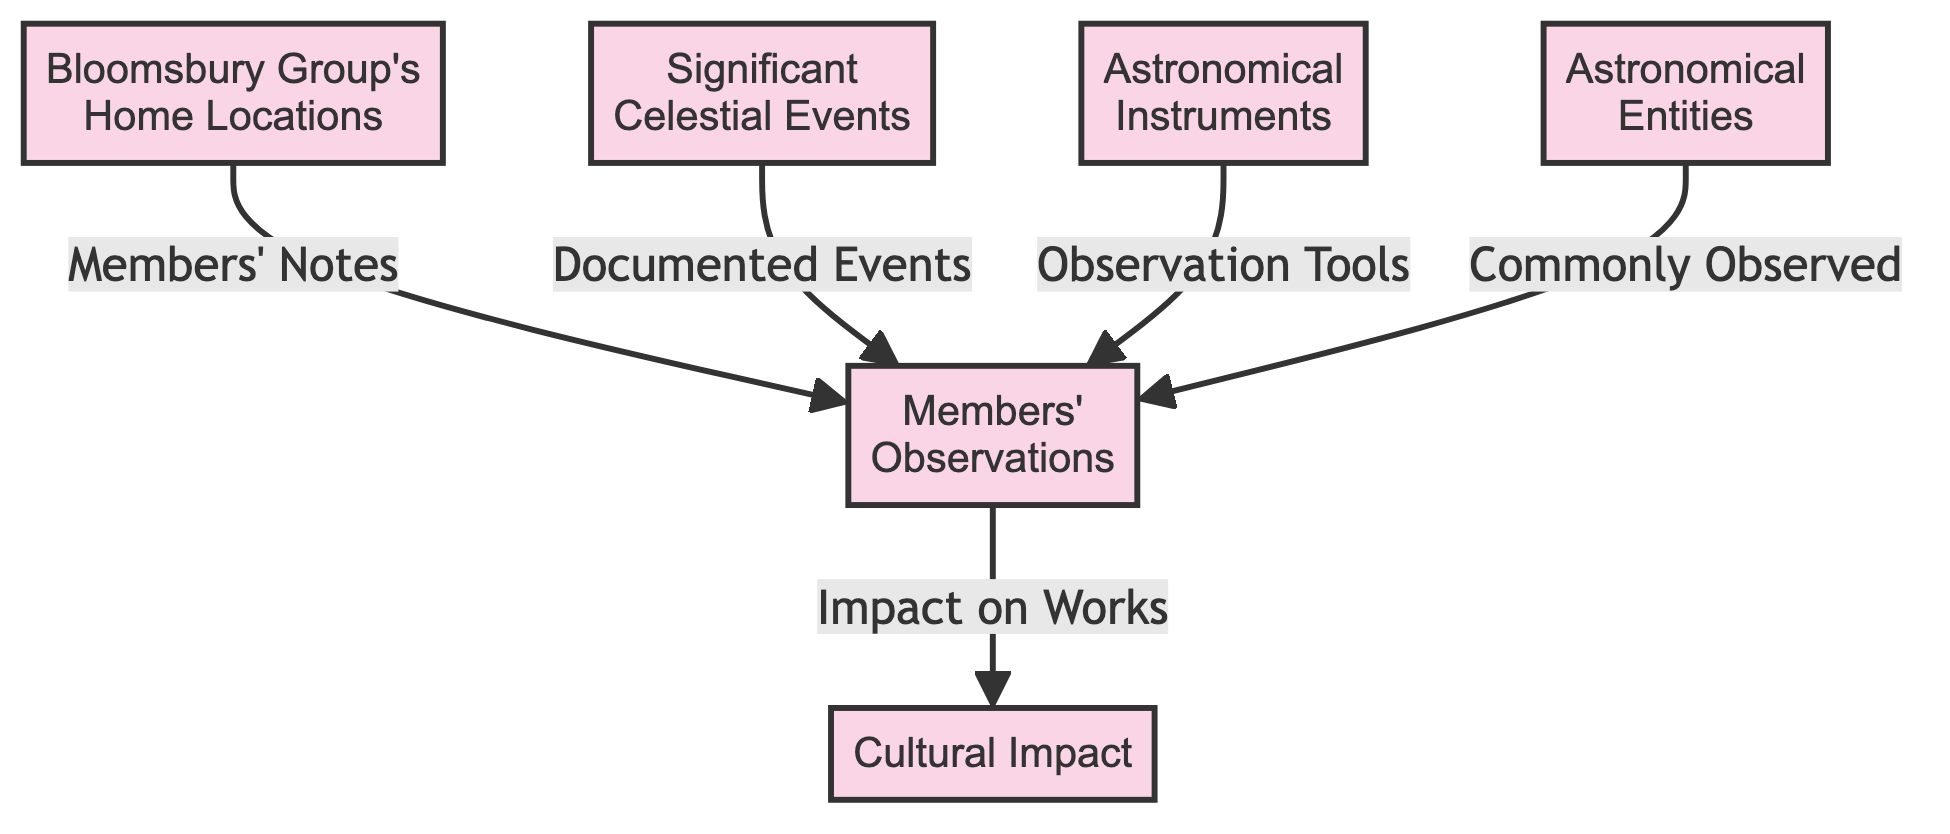How many main nodes are in the diagram? The diagram contains six main nodes which include the titles at the top of each section, representing the various aspects of the Bloomsbury Group's astronomical interests.
Answer: 6 What type of relationship exists between 'Significant Celestial Events' and 'Members' Observations'? The relationship is indicated by the edge labeled 'Documented Events' which points from 'Significant Celestial Events' to 'Members' Observations.' This shows that the documented celestial events led to observations made by members.
Answer: Documented Events Which node is influenced by 'Members’ Notes'? The node 'Members' Observations' is influenced by 'Members’ Notes', as indicated by the arrow connecting them. This means that the notes taken by the members directly contribute to their observations.
Answer: Members' Observations What flows from 'Astronomical Instruments' to 'Members' Observations'? The flow from 'Astronomical Instruments' to 'Members' Observations' is labeled 'Observation Tools', indicating that the tools used for observations are the instruments classified under 'Astronomical Instruments'.
Answer: Observation Tools What are the implications of 'Members' Observations' on 'Cultural Impact'? The flow indicates that 'Members' Observations' have an impact on 'Cultural Impact', suggesting that the findings and notes from the observations influenced cultural expressions and thought.
Answer: Impact on Works How many arrows connect to the 'Members' Observations' node? There are five arrows connecting to the 'Members' Observations' node, indicating multiple influences such as notes, events, instruments, and entities, highlighting the collaborative effort in celestial observations.
Answer: 5 What does 'Commonly Observed' refer to in the context of the diagram? 'Commonly Observed' refers to the types of 'Astronomical Entities' that were frequently noted by the members of the Bloomsbury Group during their celestial observations.
Answer: Astronomical Entities What significance does the 'Cultural Impact' node hold in the flow diagram? The 'Cultural Impact' node signifies the outcomes and influences that arose from the members' observations of celestial phenomena, affecting the cultural background of the Bloomsbury Group's contributions.
Answer: Cultural Impact What type of events are related to the 'Members' Observations'? The events related to the 'Members' Observations' are termed 'Documented Events', which represent the celestial phenomena that members noted and observed.
Answer: Documented Events 